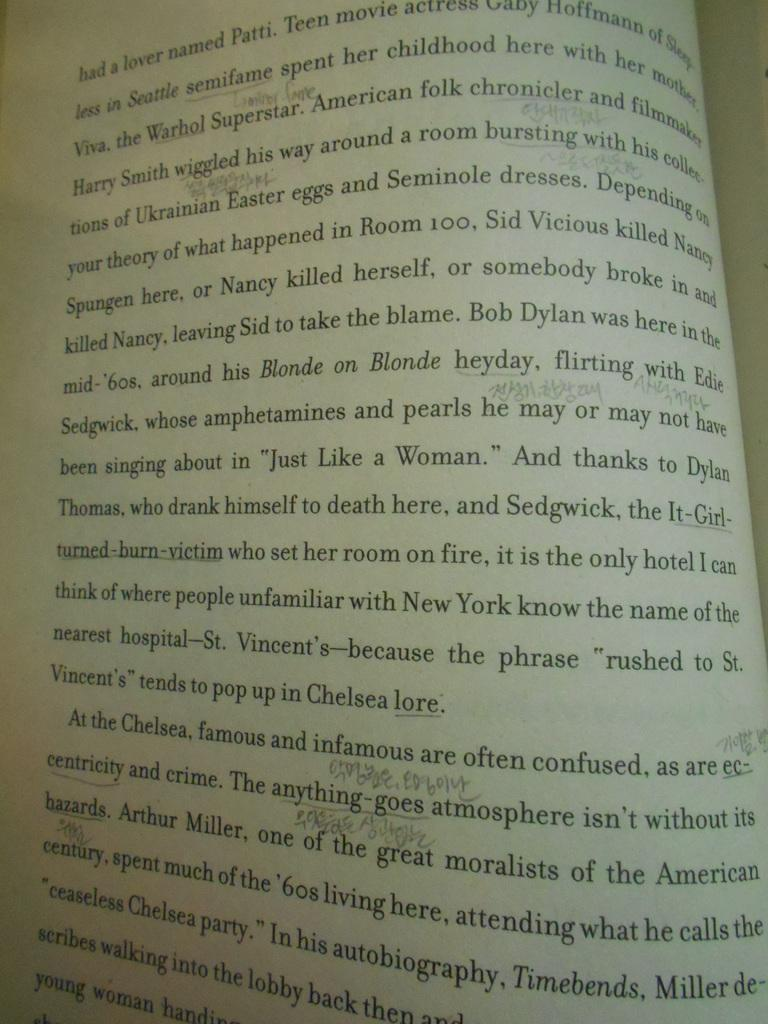<image>
Write a terse but informative summary of the picture. Bob Dylan is being discussed on the open page of this book. 